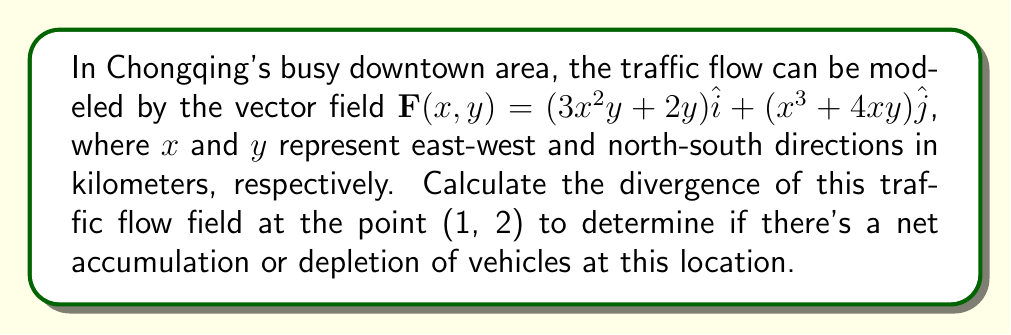Show me your answer to this math problem. To solve this problem, we need to follow these steps:

1) The divergence of a vector field $\mathbf{F}(x,y) = P(x,y)\hat{i} + Q(x,y)\hat{j}$ in 2D is given by:

   $$\text{div}\mathbf{F} = \nabla \cdot \mathbf{F} = \frac{\partial P}{\partial x} + \frac{\partial Q}{\partial y}$$

2) In our case, $P(x,y) = 3x^2y + 2y$ and $Q(x,y) = x^3 + 4xy$

3) Let's calculate $\frac{\partial P}{\partial x}$:
   
   $$\frac{\partial P}{\partial x} = \frac{\partial}{\partial x}(3x^2y + 2y) = 6xy$$

4) Now, let's calculate $\frac{\partial Q}{\partial y}$:
   
   $$\frac{\partial Q}{\partial y} = \frac{\partial}{\partial y}(x^3 + 4xy) = 4x$$

5) The divergence is the sum of these partial derivatives:

   $$\text{div}\mathbf{F} = \frac{\partial P}{\partial x} + \frac{\partial Q}{\partial y} = 6xy + 4x$$

6) We need to evaluate this at the point (1, 2):

   $$\text{div}\mathbf{F}(1,2) = 6(1)(2) + 4(1) = 12 + 4 = 16$$

The positive divergence indicates a net accumulation of vehicles at this location.
Answer: 16 vehicles/km² 